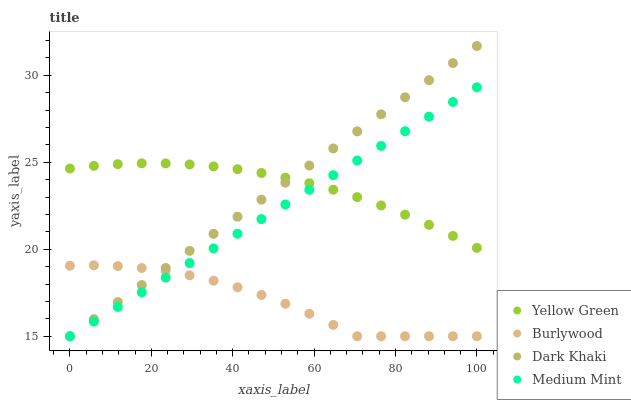Does Burlywood have the minimum area under the curve?
Answer yes or no. Yes. Does Yellow Green have the maximum area under the curve?
Answer yes or no. Yes. Does Dark Khaki have the minimum area under the curve?
Answer yes or no. No. Does Dark Khaki have the maximum area under the curve?
Answer yes or no. No. Is Dark Khaki the smoothest?
Answer yes or no. Yes. Is Burlywood the roughest?
Answer yes or no. Yes. Is Yellow Green the smoothest?
Answer yes or no. No. Is Yellow Green the roughest?
Answer yes or no. No. Does Burlywood have the lowest value?
Answer yes or no. Yes. Does Yellow Green have the lowest value?
Answer yes or no. No. Does Dark Khaki have the highest value?
Answer yes or no. Yes. Does Yellow Green have the highest value?
Answer yes or no. No. Is Burlywood less than Yellow Green?
Answer yes or no. Yes. Is Yellow Green greater than Burlywood?
Answer yes or no. Yes. Does Dark Khaki intersect Medium Mint?
Answer yes or no. Yes. Is Dark Khaki less than Medium Mint?
Answer yes or no. No. Is Dark Khaki greater than Medium Mint?
Answer yes or no. No. Does Burlywood intersect Yellow Green?
Answer yes or no. No. 